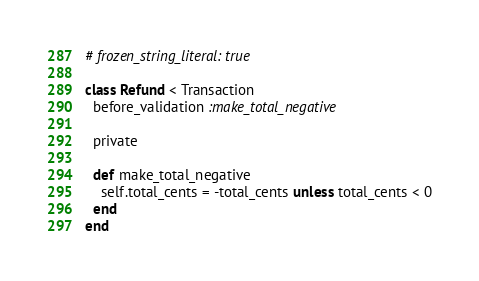<code> <loc_0><loc_0><loc_500><loc_500><_Ruby_># frozen_string_literal: true

class Refund < Transaction
  before_validation :make_total_negative

  private

  def make_total_negative
    self.total_cents = -total_cents unless total_cents < 0
  end
end
</code> 